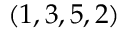<formula> <loc_0><loc_0><loc_500><loc_500>( 1 , 3 , 5 , 2 )</formula> 